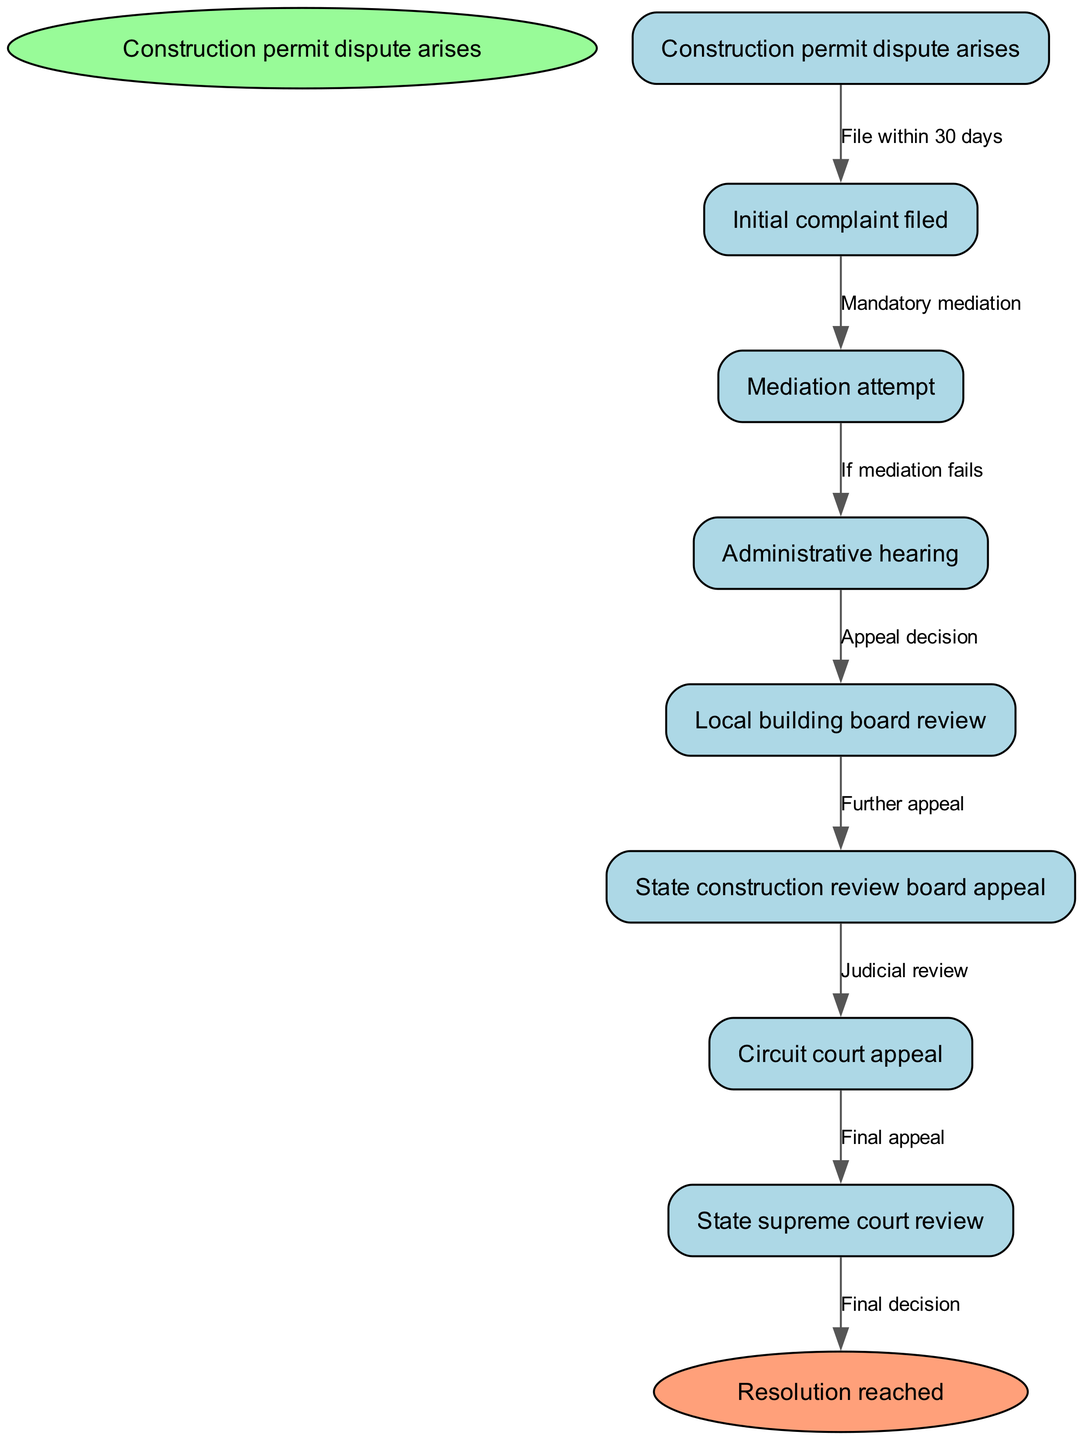What's the first step in the clinical pathway? The first step is the initial action taken when a construction permit dispute arises, which is to file a complaint within 30 days.
Answer: Initial complaint filed How many nodes are there in the diagram? The diagram includes one start node, seven intermediate nodes, and one end node, totaling nine nodes.
Answer: Nine What is the label on the edge from the 'Mediation attempt' to 'Administrative hearing'? The edge indicates the next step in the pathway if mediation has failed, represented by a specific condition.
Answer: If mediation fails What follows after the 'Local building board review'? The next step in the process after the local building board review is an appeal to the state construction review board.
Answer: State construction review board appeal If mediation is unsuccessful, which step occurs next? The sequence of steps indicates that the next step, if mediation fails, is to proceed to an administrative hearing.
Answer: Administrative hearing How does a party reach the state supreme court? The pathway outlines the steps leading to the state supreme court, which follow the necessary appeals from the circuit court.
Answer: Circuit court appeal What is the last node in the diagram? The end node represents the final outcome in this clinical pathway, which is the resolution of the dispute.
Answer: Resolution reached Which step occurs immediately after the 'Administrative hearing'? The node directly following the administrative hearing is the local building board review, indicating the next level of appeal.
Answer: Local building board review What decision is made after the 'Circuit court appeal'? The decision made after this stage may lead a party to make a final appeal to the state supreme court, indicating the continuation of the process.
Answer: State supreme court review 